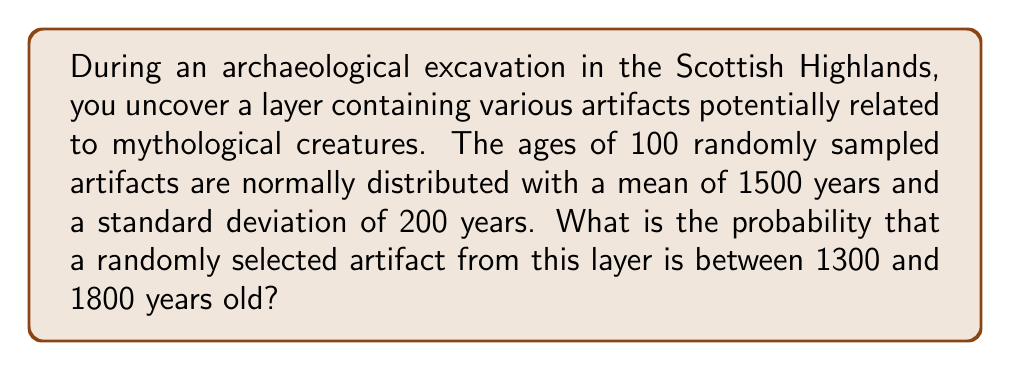Help me with this question. To solve this problem, we need to use the properties of the normal distribution and the concept of z-scores.

1. Given information:
   - The ages are normally distributed
   - Mean (μ) = 1500 years
   - Standard deviation (σ) = 200 years
   - We want to find P(1300 < X < 1800)

2. Calculate the z-scores for the lower and upper bounds:
   $$z_1 = \frac{1300 - 1500}{200} = -1$$
   $$z_2 = \frac{1800 - 1500}{200} = 1.5$$

3. The probability we're looking for is the area under the standard normal curve between z = -1 and z = 1.5.

4. Using a standard normal distribution table or calculator:
   P(Z < -1) = 0.1587
   P(Z < 1.5) = 0.9332

5. The probability is the difference between these two values:
   P(-1 < Z < 1.5) = 0.9332 - 0.1587 = 0.7745

Therefore, the probability that a randomly selected artifact from this layer is between 1300 and 1800 years old is approximately 0.7745 or 77.45%.
Answer: 0.7745 or 77.45% 